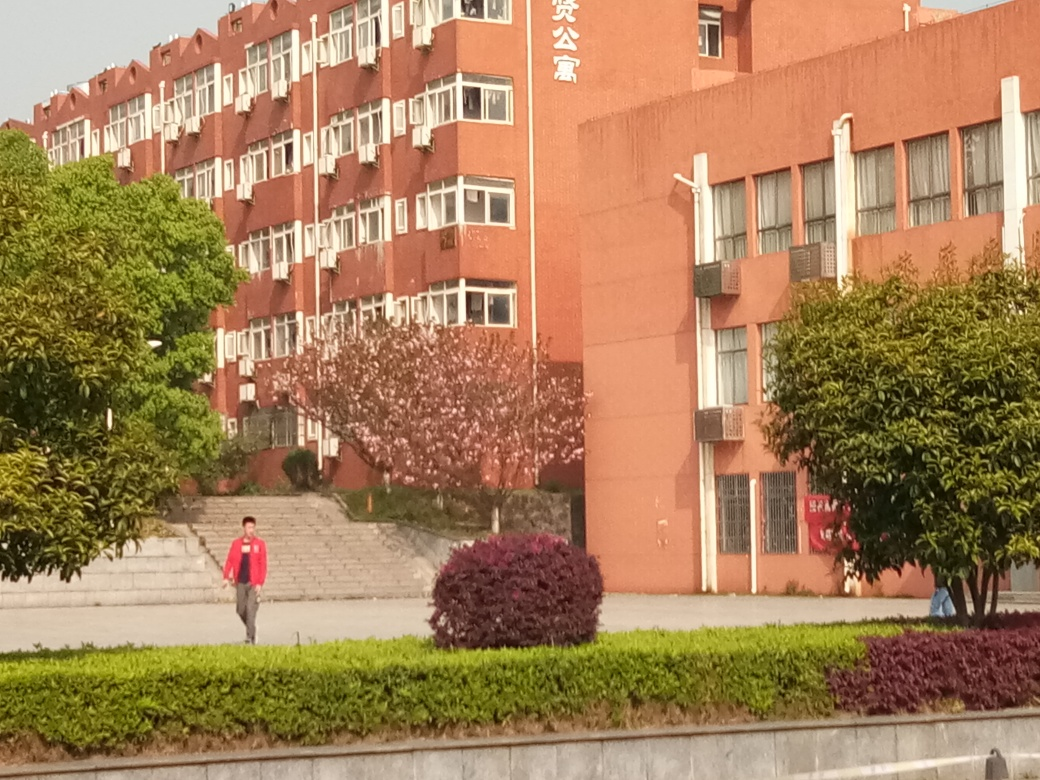What time of year does this image appear to have been taken and why? The image likely captures a scene during springtime. This is indicated by the blossoming trees with pink flowers, which are commonly associated with this season. Additionally, the attire of the individual in the picture appears light, suggesting a temperate climate. 